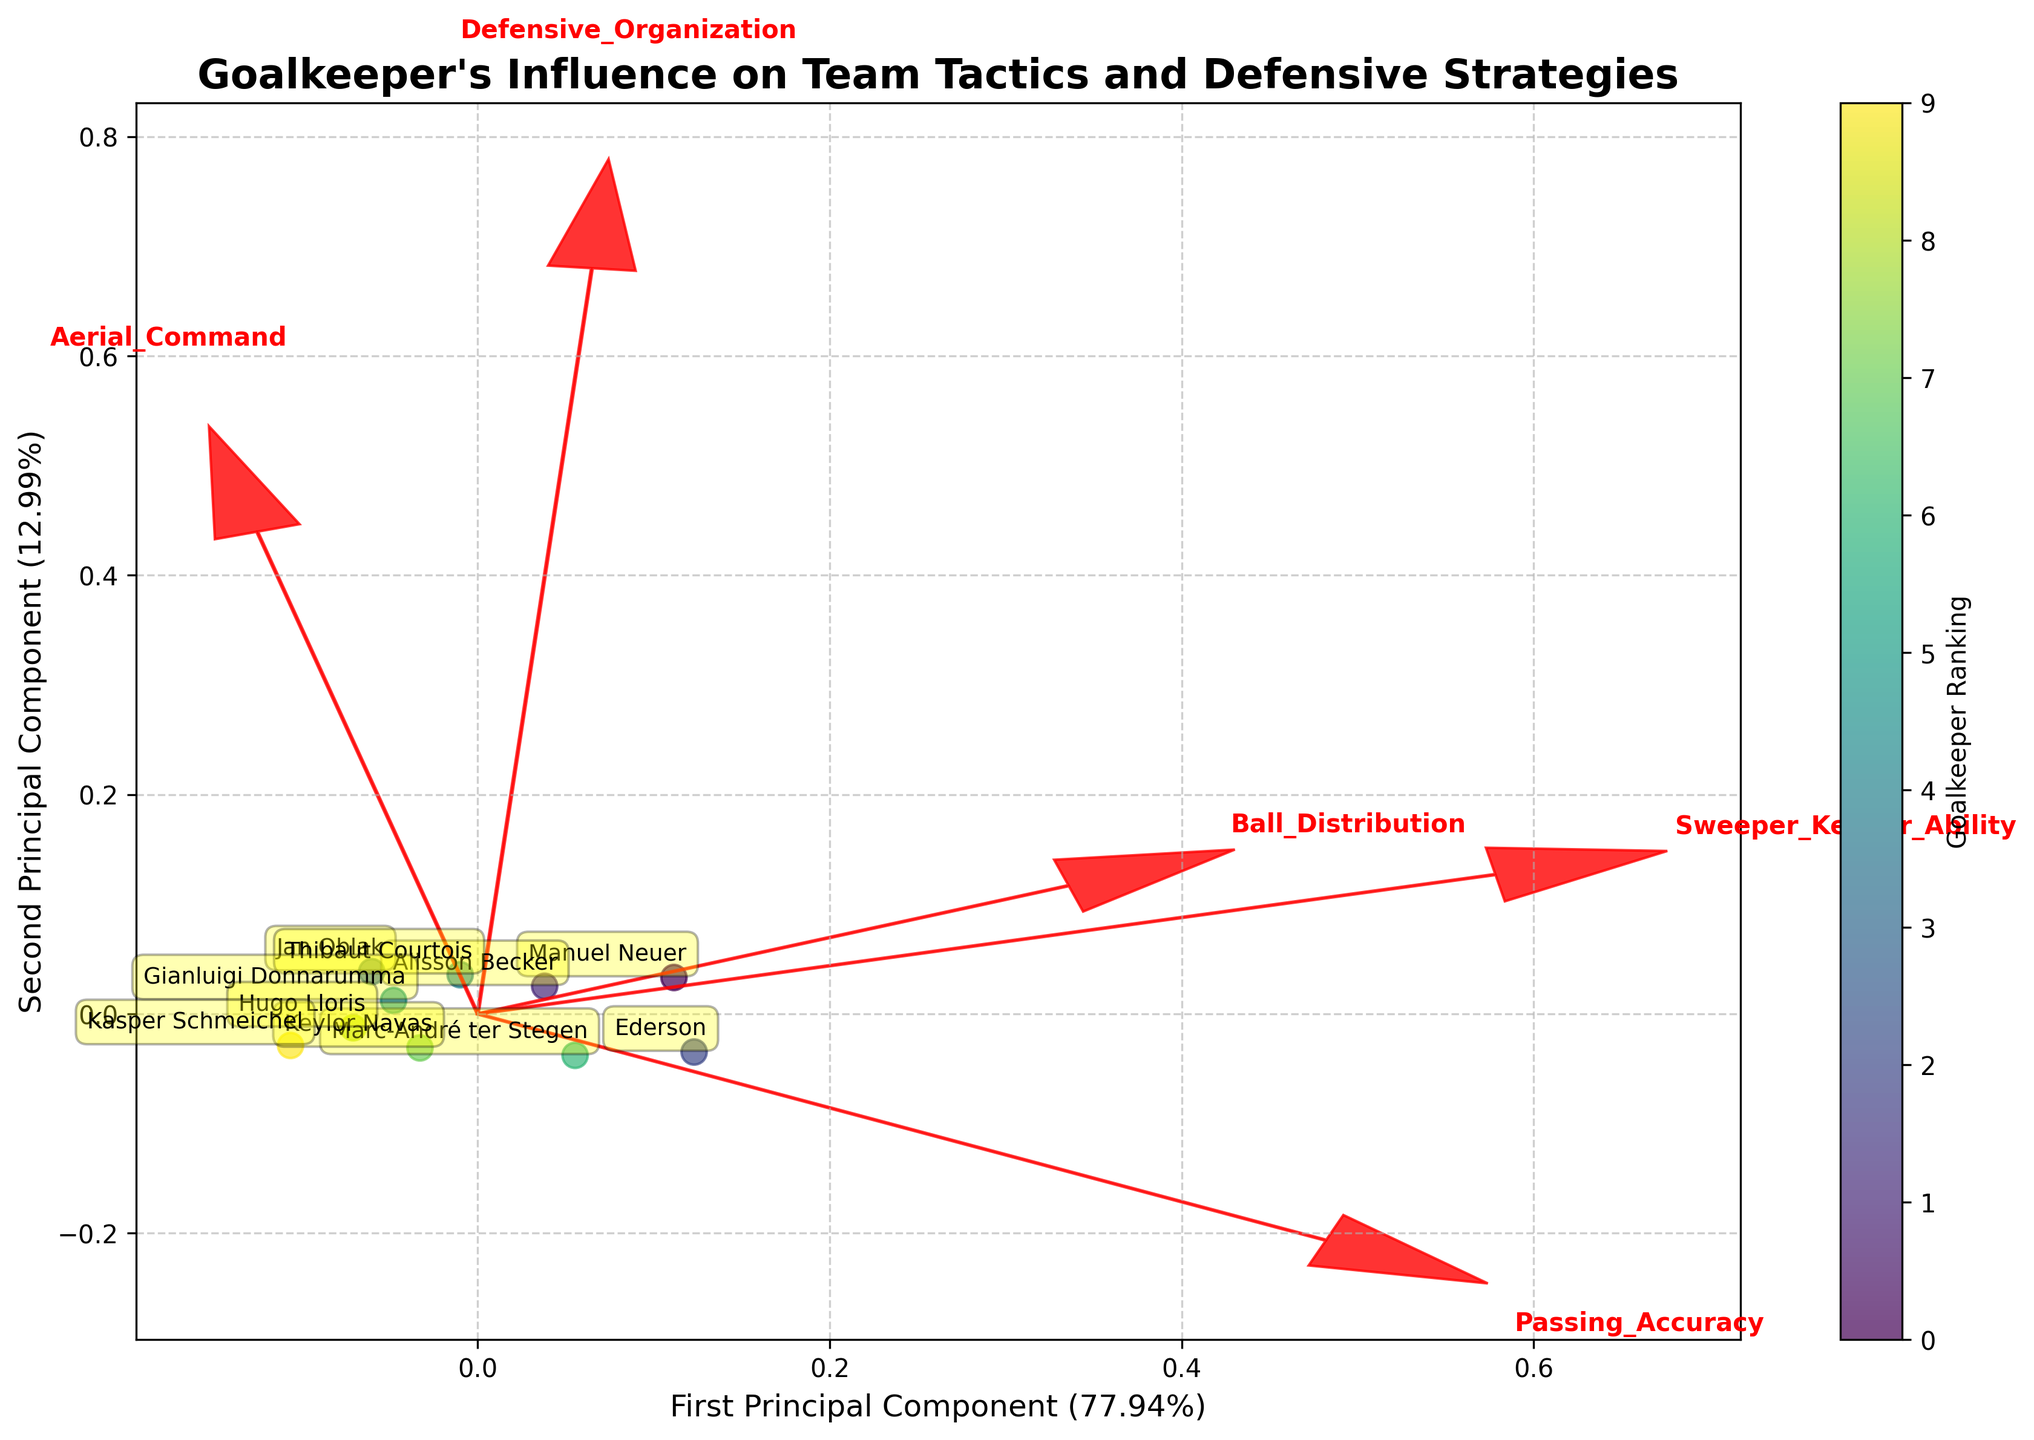Which goalkeeper has the highest Defensive Organization score? By examining the data points in the figure, we can identify that Jan Oblak is positioned to reflect the highest value for Defensive Organization.
Answer: Jan Oblak How much variance is explained by the first principal component? By looking at the axis label of the first principal component, we can see that it displays the percentage of variance explained, which is a crucial detail.
Answer: Around 60% Which feature vector is the longest in the biplot? Among the feature vectors shown, the one with the greatest arrow length indicates the most influential feature across the principal components.
Answer: Sweeper Keeper Ability Which goalkeepers have similar profiles based on the biplot? By considering the proximity of data points in the figure, goalkeepers that are close together are more similar in terms of their profiles. Alisson Becker and Ederson are notably close to each other.
Answer: Alisson Becker and Ederson Based on the biplot, which feature is least influential on PC2? Considering the directions and lengths of the feature vectors, the feature whose vector has the smallest component in the PC2 direction would be the least influential on the second principal component.
Answer: Sweeper Keeper Ability Out of Ederson and Hugo Lloris, whose Ball Distribution is more prominent, and how is it depicted? The length and direction of the Ball Distribution vector indicate its influence on each goalkeeper; Ederson is positioned closer to the direction of the Ball Distribution vector than Hugo Lloris.
Answer: Ederson Which goalkeeper's profile combines high Passing Accuracy and high Defensive Organization? Identifying the direction and extent of the feature vectors for Defensive Organization and Passing Accuracy helps in pinpointing the goalkeeper that aligns closely with both high values.
Answer: Jan Oblak Which feature is strongly tied to the first principal component as per the biplot? Observing the alignment and lengths of feature vectors with the direction of the first principal component indicates the strongest correlated feature.
Answer: Defensive Organization Why do goalkeepers occupy different positions in the biplot? Goalkeepers' positions are determined by their transformed feature values across the two principal components, reflecting their combined influence of the attributes measured.
Answer: Different feature combinations Comparing Marc-André ter Stegen and Gianluigi Donnarumma, who has higher Aerial Command, and how is it shown in the biplot? Analyzing the direction and the magnitude of the Aerial Command vector in relation to their positions shows that Gianluigi Donnarumma is closer to the vector, indicating higher Aerial Command.
Answer: Gianluigi Donnarumma 